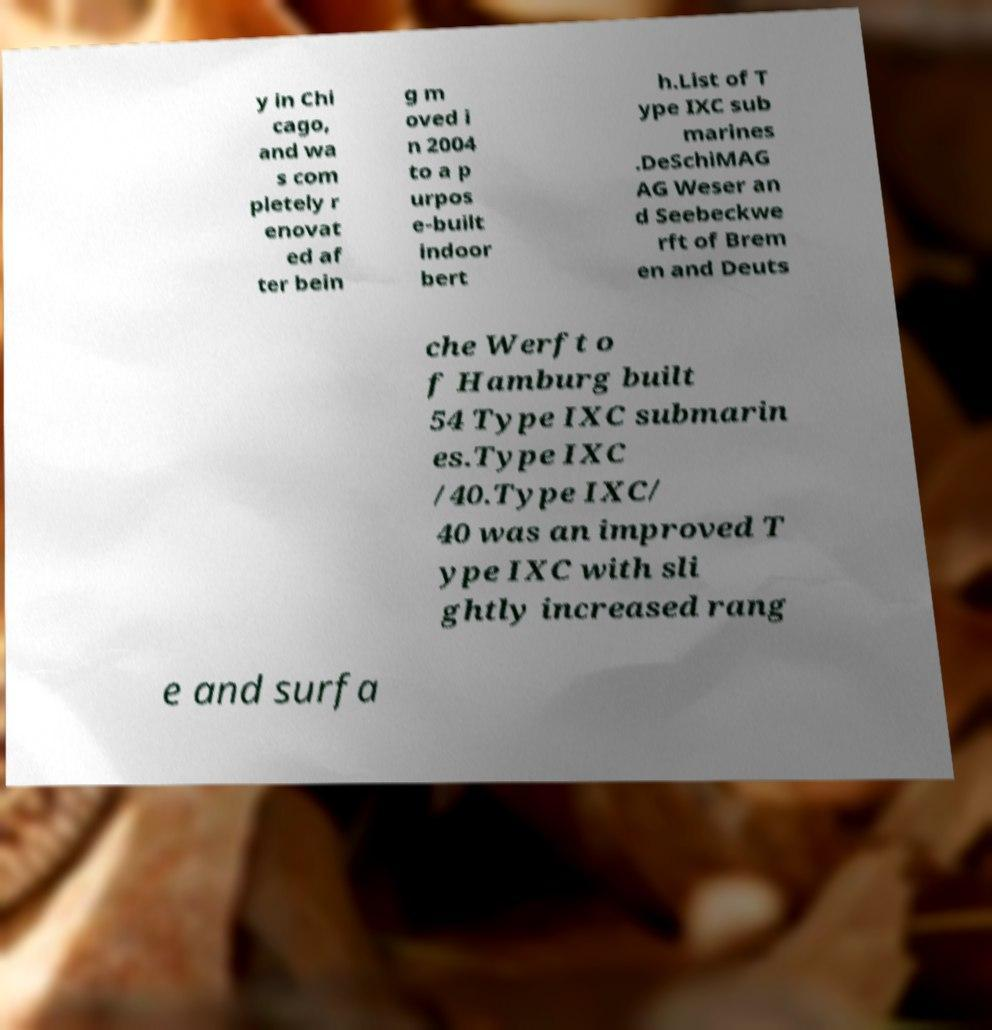Please identify and transcribe the text found in this image. y in Chi cago, and wa s com pletely r enovat ed af ter bein g m oved i n 2004 to a p urpos e-built indoor bert h.List of T ype IXC sub marines .DeSchiMAG AG Weser an d Seebeckwe rft of Brem en and Deuts che Werft o f Hamburg built 54 Type IXC submarin es.Type IXC /40.Type IXC/ 40 was an improved T ype IXC with sli ghtly increased rang e and surfa 